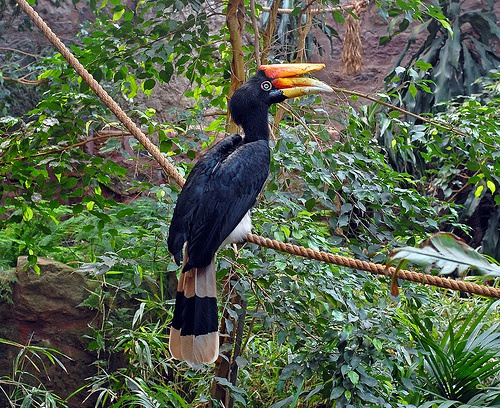Describe the objects in this image and their specific colors. I can see a bird in black, navy, and gray tones in this image. 